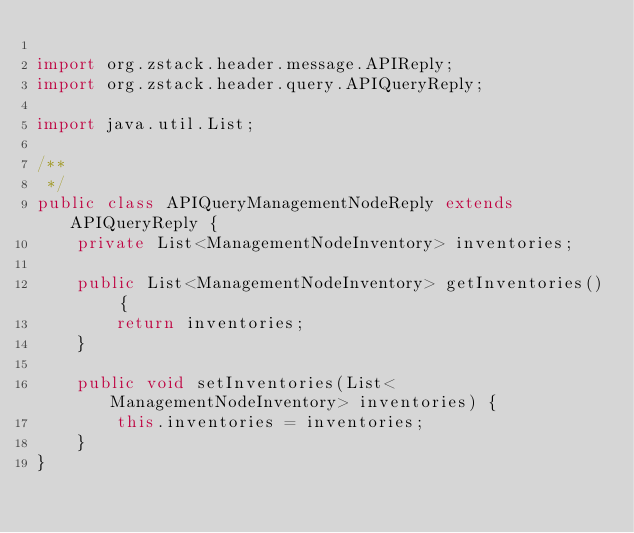<code> <loc_0><loc_0><loc_500><loc_500><_Java_>
import org.zstack.header.message.APIReply;
import org.zstack.header.query.APIQueryReply;

import java.util.List;

/**
 */
public class APIQueryManagementNodeReply extends APIQueryReply {
    private List<ManagementNodeInventory> inventories;

    public List<ManagementNodeInventory> getInventories() {
        return inventories;
    }

    public void setInventories(List<ManagementNodeInventory> inventories) {
        this.inventories = inventories;
    }
}
</code> 